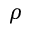<formula> <loc_0><loc_0><loc_500><loc_500>\rho</formula> 